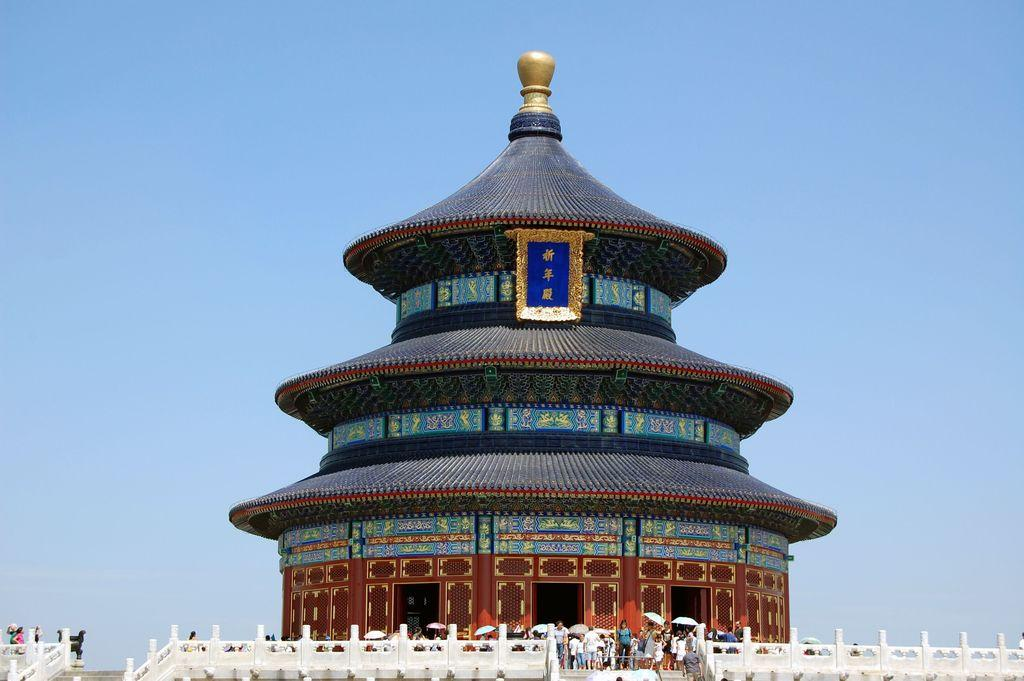What type of structure can be seen in the image? There is a building in the image. Are there any architectural features visible in the image? Yes, there are stairs and a fence in the image. Can you describe the people in the image? There are people present in the image. What might the people be using to protect themselves from the weather? Umbrellas are present in the image. What is visible in the background of the image? The sky is visible in the image. What type of toe can be seen expanding in the image? There is no toe present in the image, and therefore no expansion can be observed. 